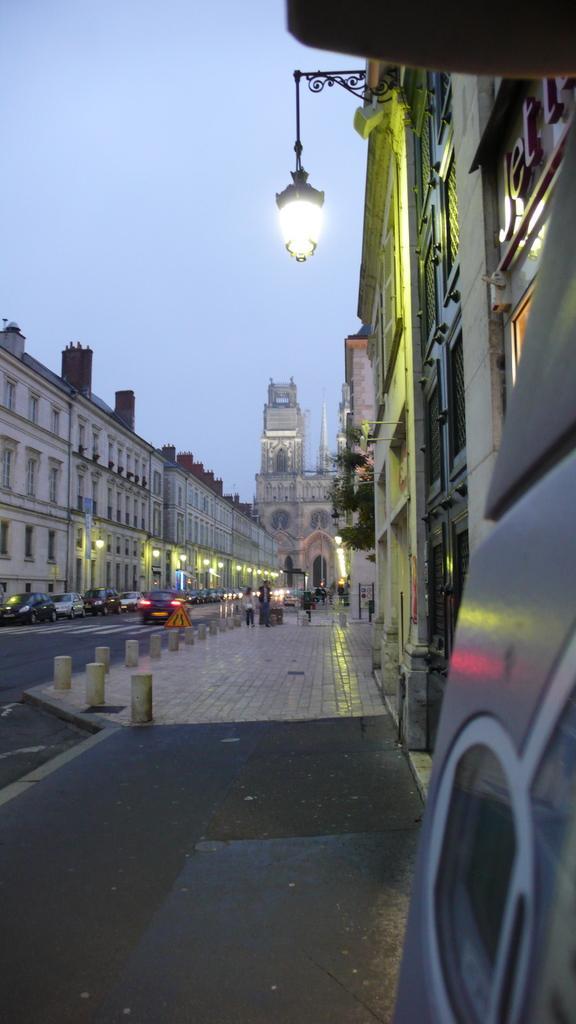Could you give a brief overview of what you see in this image? In this image we can see buildings with windows, light poles, vehicles, sky and we can also see some people standing on the road. 